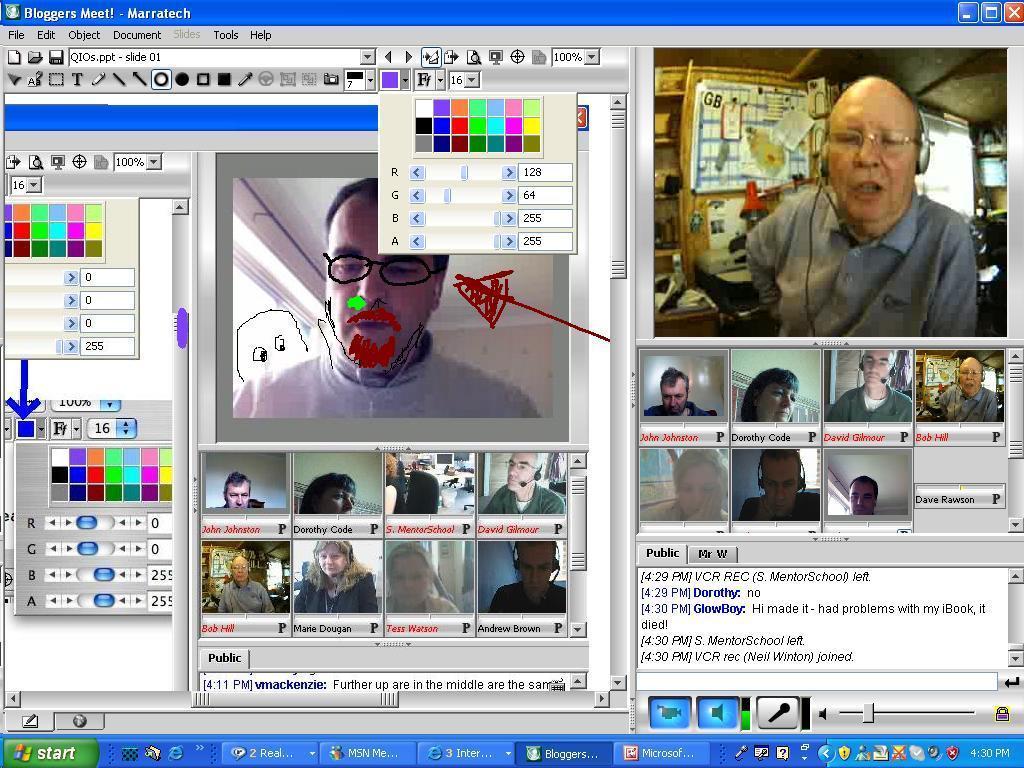Please provide a concise description of this image. In this image there is a desktop screen of a computer with different tabs opened. 